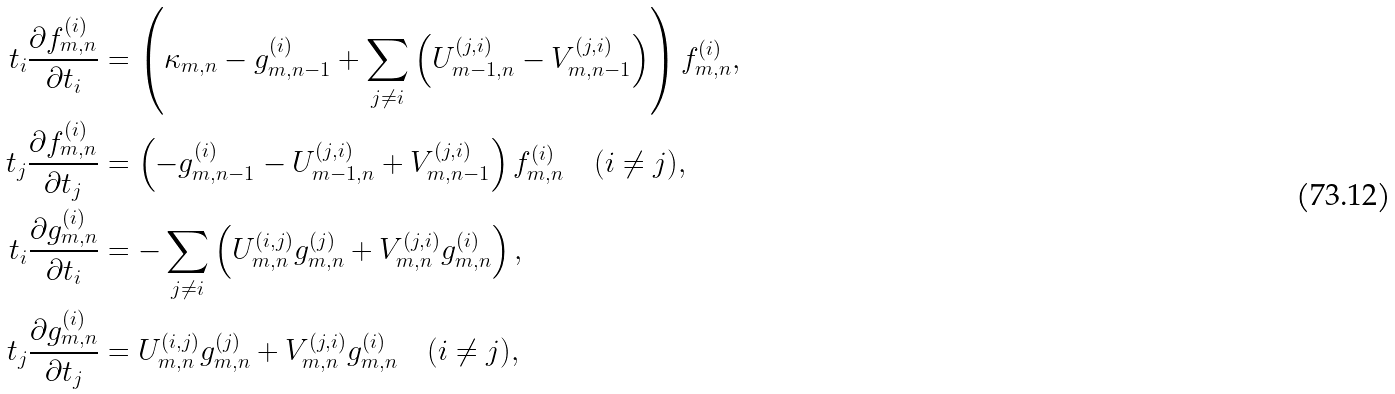<formula> <loc_0><loc_0><loc_500><loc_500>t _ { i } \frac { \partial f _ { m , n } ^ { ( i ) } } { \partial t _ { i } } & = \left ( \kappa _ { m , n } - g _ { m , n - 1 } ^ { ( i ) } + \sum _ { j \neq i } \left ( U _ { m - 1 , n } ^ { ( j , i ) } - V _ { m , n - 1 } ^ { ( j , i ) } \right ) \right ) f _ { m , n } ^ { ( i ) } , \\ t _ { j } \frac { \partial f _ { m , n } ^ { ( i ) } } { \partial t _ { j } } & = \left ( - g _ { m , n - 1 } ^ { ( i ) } - U _ { m - 1 , n } ^ { ( j , i ) } + V _ { m , n - 1 } ^ { ( j , i ) } \right ) f _ { m , n } ^ { ( i ) } \quad ( i \neq j ) , \\ t _ { i } \frac { \partial g _ { m , n } ^ { ( i ) } } { \partial t _ { i } } & = - \sum _ { j \neq i } \left ( U _ { m , n } ^ { ( i , j ) } g _ { m , n } ^ { ( j ) } + V _ { m , n } ^ { ( j , i ) } g _ { m , n } ^ { ( i ) } \right ) , \\ t _ { j } \frac { \partial g _ { m , n } ^ { ( i ) } } { \partial t _ { j } } & = U _ { m , n } ^ { ( i , j ) } g _ { m , n } ^ { ( j ) } + V _ { m , n } ^ { ( j , i ) } g _ { m , n } ^ { ( i ) } \quad ( i \neq j ) ,</formula> 